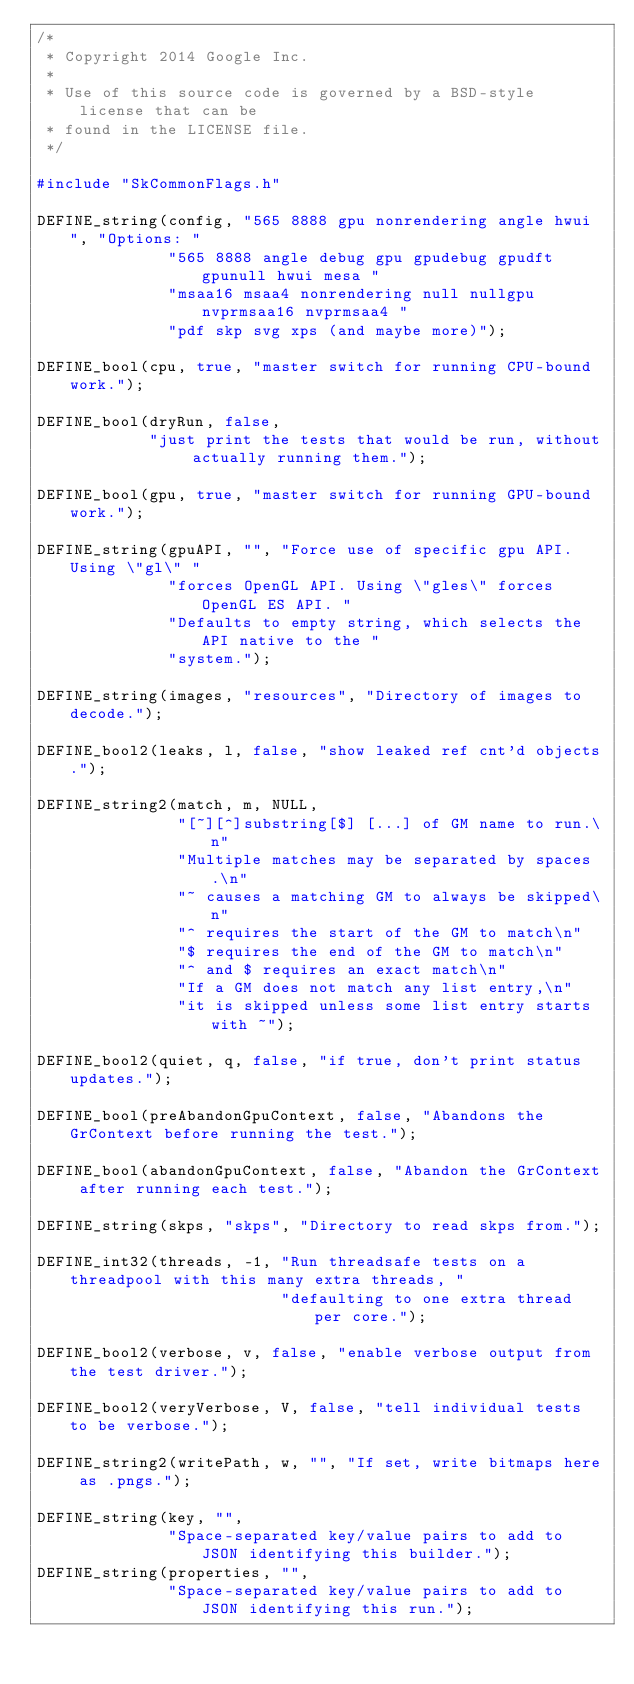<code> <loc_0><loc_0><loc_500><loc_500><_C++_>/*
 * Copyright 2014 Google Inc.
 *
 * Use of this source code is governed by a BSD-style license that can be
 * found in the LICENSE file.
 */

#include "SkCommonFlags.h"

DEFINE_string(config, "565 8888 gpu nonrendering angle hwui ", "Options: "
              "565 8888 angle debug gpu gpudebug gpudft gpunull hwui mesa "
              "msaa16 msaa4 nonrendering null nullgpu nvprmsaa16 nvprmsaa4 "
              "pdf skp svg xps (and maybe more)");

DEFINE_bool(cpu, true, "master switch for running CPU-bound work.");

DEFINE_bool(dryRun, false,
            "just print the tests that would be run, without actually running them.");

DEFINE_bool(gpu, true, "master switch for running GPU-bound work.");

DEFINE_string(gpuAPI, "", "Force use of specific gpu API.  Using \"gl\" "
              "forces OpenGL API. Using \"gles\" forces OpenGL ES API. "
              "Defaults to empty string, which selects the API native to the "
              "system.");

DEFINE_string(images, "resources", "Directory of images to decode.");

DEFINE_bool2(leaks, l, false, "show leaked ref cnt'd objects.");

DEFINE_string2(match, m, NULL,
               "[~][^]substring[$] [...] of GM name to run.\n"
               "Multiple matches may be separated by spaces.\n"
               "~ causes a matching GM to always be skipped\n"
               "^ requires the start of the GM to match\n"
               "$ requires the end of the GM to match\n"
               "^ and $ requires an exact match\n"
               "If a GM does not match any list entry,\n"
               "it is skipped unless some list entry starts with ~");

DEFINE_bool2(quiet, q, false, "if true, don't print status updates.");

DEFINE_bool(preAbandonGpuContext, false, "Abandons the GrContext before running the test.");

DEFINE_bool(abandonGpuContext, false, "Abandon the GrContext after running each test.");

DEFINE_string(skps, "skps", "Directory to read skps from.");

DEFINE_int32(threads, -1, "Run threadsafe tests on a threadpool with this many extra threads, "
                          "defaulting to one extra thread per core.");

DEFINE_bool2(verbose, v, false, "enable verbose output from the test driver.");

DEFINE_bool2(veryVerbose, V, false, "tell individual tests to be verbose.");

DEFINE_string2(writePath, w, "", "If set, write bitmaps here as .pngs.");

DEFINE_string(key, "",
              "Space-separated key/value pairs to add to JSON identifying this builder.");
DEFINE_string(properties, "",
              "Space-separated key/value pairs to add to JSON identifying this run.");

</code> 